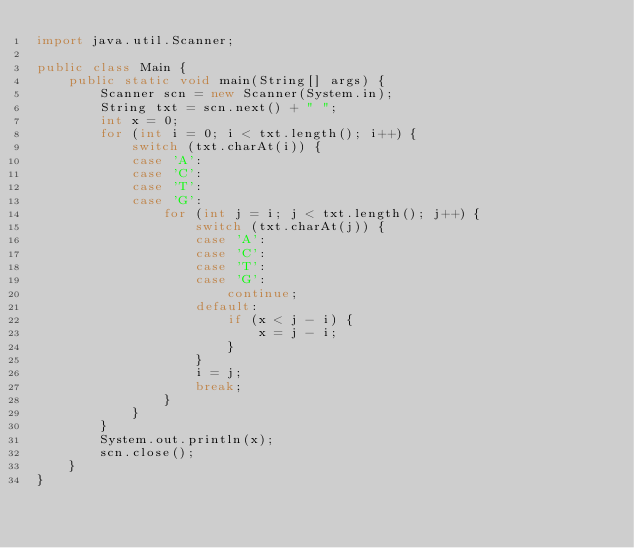Convert code to text. <code><loc_0><loc_0><loc_500><loc_500><_Java_>import java.util.Scanner;

public class Main {
	public static void main(String[] args) {
		Scanner scn = new Scanner(System.in);
		String txt = scn.next() + " ";
		int x = 0;
		for (int i = 0; i < txt.length(); i++) {
			switch (txt.charAt(i)) {
			case 'A':
			case 'C':
			case 'T':
			case 'G':
				for (int j = i; j < txt.length(); j++) {
					switch (txt.charAt(j)) {
					case 'A':
					case 'C':
					case 'T':
					case 'G':
						continue;
					default:
						if (x < j - i) {
							x = j - i;
						}
					}
					i = j;
					break;
				}
			}
		}
		System.out.println(x);
		scn.close();
	}
}</code> 